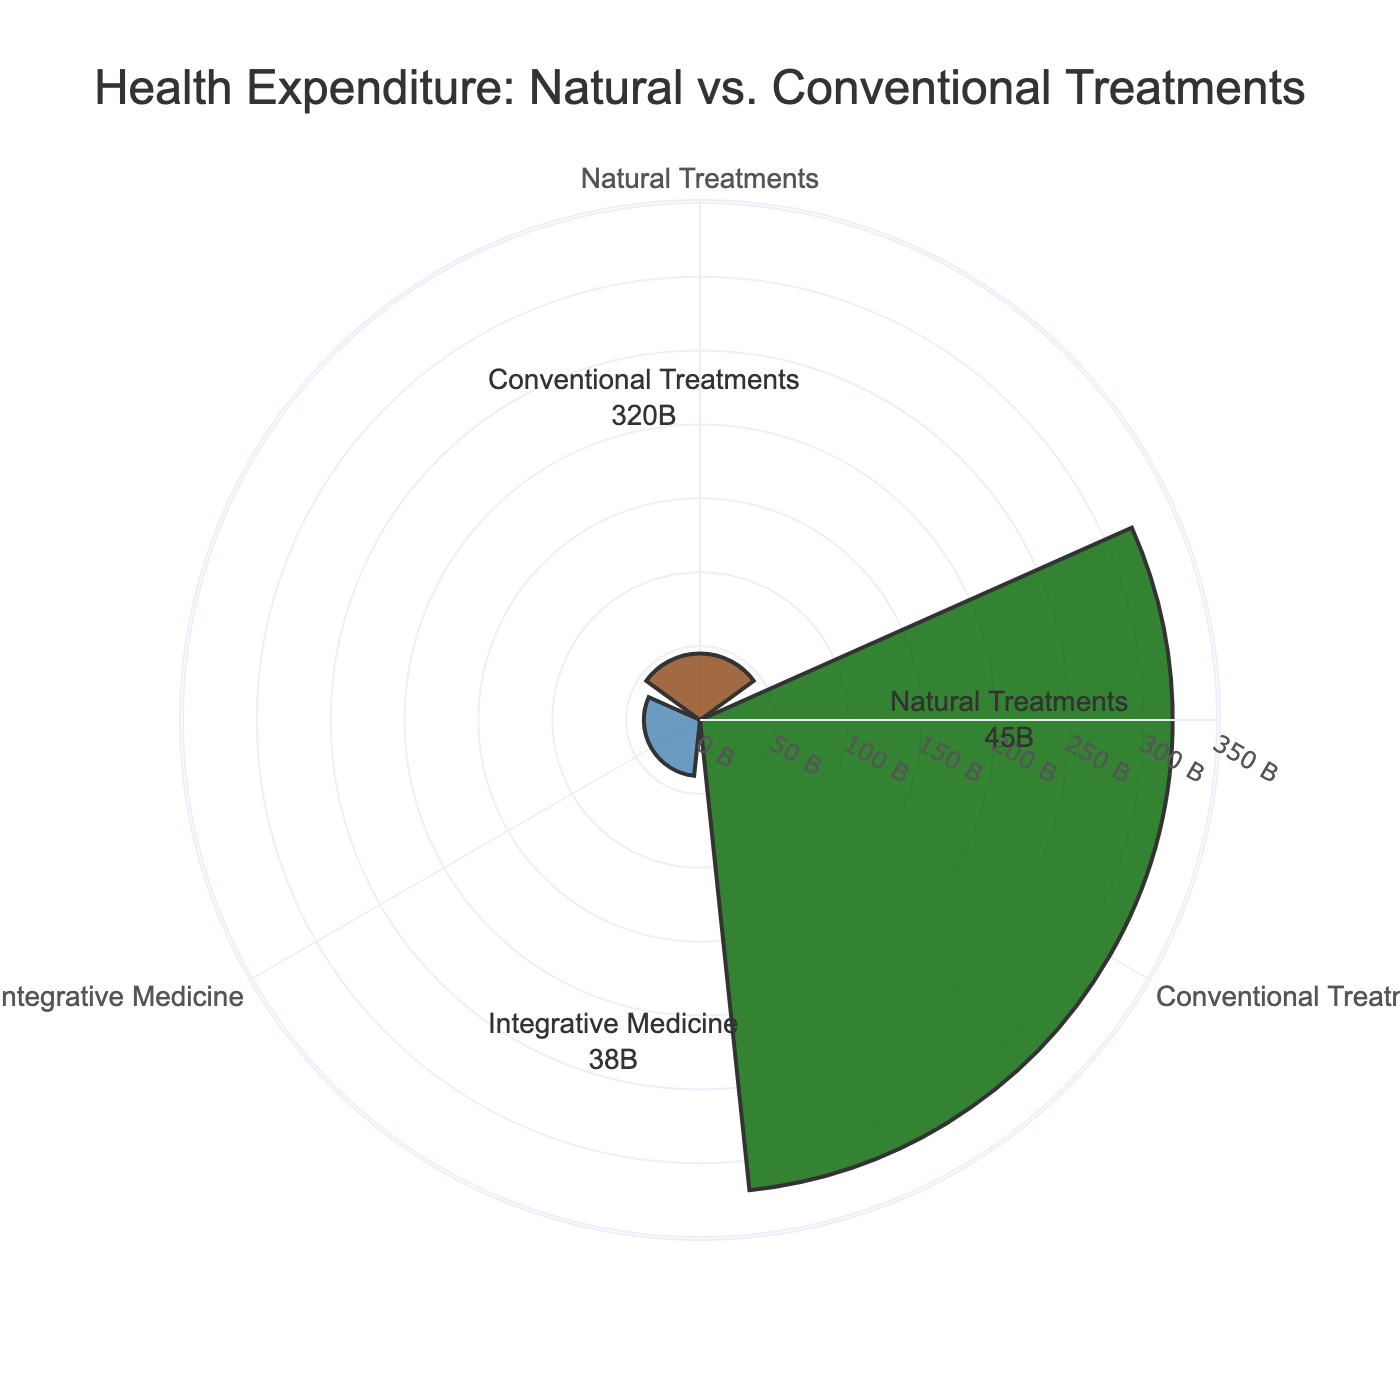What is the title of the figure? The title of the figure is displayed at the top center of the chart. It reads "Health Expenditure: Natural vs. Conventional Treatments".
Answer: Health Expenditure: Natural vs. Conventional Treatments What are the categories shown in the chart? The categories are labeled around the circle of the rose chart. They include "Natural Treatments", "Conventional Treatments", and "Integrative Medicine".
Answer: Natural Treatments, Conventional Treatments, Integrative Medicine Which category has the highest spending? By observing the lengths of the bars in the rose chart, we can see that "Conventional Treatments" has the highest spending.
Answer: Conventional Treatments How much is spent on Integrative Medicine? The annotation for "Integrative Medicine" shows its spending, which is 38 billion dollars.
Answer: 38 billion dollars What is the total spending on all categories combined? Adding the expenditures from all three categories: Natural Treatments (45 billion) + Conventional Treatments (320 billion) + Integrative Medicine (38 billion) results in a total of 403 billion.
Answer: 403 billion How does the spending on Natural Treatments compare to that on Integrative Medicine? By looking at the annotated values and the lengths of the bars, we see that spending on Natural Treatments (45 billion) is higher than on Integrative Medicine (38 billion).
Answer: Natural Treatments have higher spending Which category has the least spending? By checking the shortest bar, we can see that "Integrative Medicine" has the least spending.
Answer: Integrative Medicine What is the difference in spending between Conventional Treatments and Natural Treatments? Subtracting the spending on Natural Treatments (45 billion) from Conventional Treatments (320 billion) gives the difference: 320 - 45 = 275 billion.
Answer: 275 billion How are the categories colored in the chart? The categories are distinguished by different bar colors: Natural Treatments is brown, Conventional Treatments is dark green, and Integrative Medicine is steel blue.
Answer: Brown (Natural Treatments), Dark Green (Conventional Treatments), Steel Blue (Integrative Medicine) What is the proportion of spending on Natural Treatments out of the total spending? The percentage can be calculated by dividing the spending on Natural Treatments by the total spending and multiplying by 100: (45 / 403) * 100 ≈ 11.2%.
Answer: 11.2% 